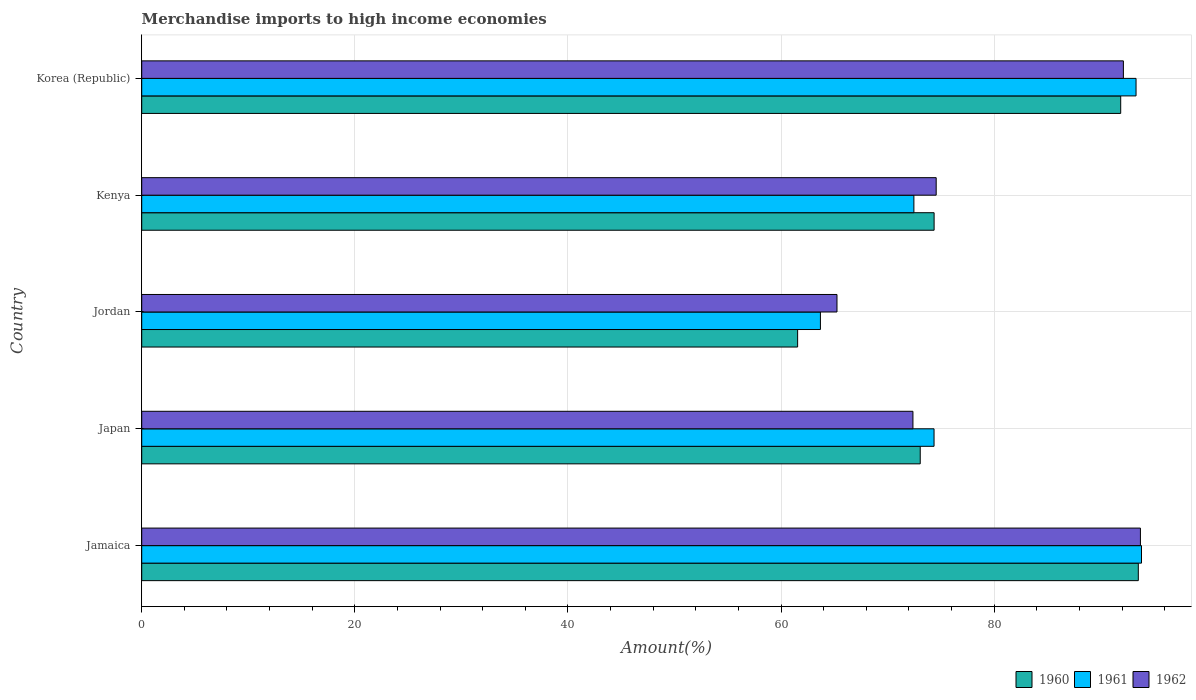How many different coloured bars are there?
Your answer should be compact. 3. How many bars are there on the 5th tick from the top?
Your answer should be compact. 3. How many bars are there on the 5th tick from the bottom?
Your answer should be very brief. 3. What is the label of the 3rd group of bars from the top?
Ensure brevity in your answer.  Jordan. What is the percentage of amount earned from merchandise imports in 1960 in Japan?
Your answer should be very brief. 73.06. Across all countries, what is the maximum percentage of amount earned from merchandise imports in 1960?
Make the answer very short. 93.52. Across all countries, what is the minimum percentage of amount earned from merchandise imports in 1962?
Provide a succinct answer. 65.24. In which country was the percentage of amount earned from merchandise imports in 1961 maximum?
Ensure brevity in your answer.  Jamaica. In which country was the percentage of amount earned from merchandise imports in 1962 minimum?
Provide a succinct answer. Jordan. What is the total percentage of amount earned from merchandise imports in 1961 in the graph?
Your response must be concise. 397.64. What is the difference between the percentage of amount earned from merchandise imports in 1962 in Jordan and that in Kenya?
Provide a short and direct response. -9.31. What is the difference between the percentage of amount earned from merchandise imports in 1962 in Jordan and the percentage of amount earned from merchandise imports in 1960 in Kenya?
Give a very brief answer. -9.11. What is the average percentage of amount earned from merchandise imports in 1960 per country?
Your response must be concise. 78.87. What is the difference between the percentage of amount earned from merchandise imports in 1961 and percentage of amount earned from merchandise imports in 1962 in Jordan?
Offer a very short reply. -1.55. What is the ratio of the percentage of amount earned from merchandise imports in 1962 in Jamaica to that in Jordan?
Keep it short and to the point. 1.44. Is the percentage of amount earned from merchandise imports in 1960 in Japan less than that in Korea (Republic)?
Make the answer very short. Yes. What is the difference between the highest and the second highest percentage of amount earned from merchandise imports in 1961?
Give a very brief answer. 0.51. What is the difference between the highest and the lowest percentage of amount earned from merchandise imports in 1961?
Keep it short and to the point. 30.13. In how many countries, is the percentage of amount earned from merchandise imports in 1962 greater than the average percentage of amount earned from merchandise imports in 1962 taken over all countries?
Provide a succinct answer. 2. Is the sum of the percentage of amount earned from merchandise imports in 1961 in Jordan and Kenya greater than the maximum percentage of amount earned from merchandise imports in 1960 across all countries?
Provide a short and direct response. Yes. What is the difference between two consecutive major ticks on the X-axis?
Your response must be concise. 20. Does the graph contain any zero values?
Ensure brevity in your answer.  No. Does the graph contain grids?
Ensure brevity in your answer.  Yes. Where does the legend appear in the graph?
Give a very brief answer. Bottom right. How many legend labels are there?
Offer a terse response. 3. What is the title of the graph?
Keep it short and to the point. Merchandise imports to high income economies. Does "2005" appear as one of the legend labels in the graph?
Keep it short and to the point. No. What is the label or title of the X-axis?
Offer a very short reply. Amount(%). What is the label or title of the Y-axis?
Offer a very short reply. Country. What is the Amount(%) in 1960 in Jamaica?
Offer a terse response. 93.52. What is the Amount(%) of 1961 in Jamaica?
Ensure brevity in your answer.  93.82. What is the Amount(%) in 1962 in Jamaica?
Provide a short and direct response. 93.72. What is the Amount(%) of 1960 in Japan?
Make the answer very short. 73.06. What is the Amount(%) of 1961 in Japan?
Keep it short and to the point. 74.35. What is the Amount(%) in 1962 in Japan?
Your answer should be very brief. 72.37. What is the Amount(%) in 1960 in Jordan?
Your answer should be compact. 61.55. What is the Amount(%) in 1961 in Jordan?
Provide a succinct answer. 63.69. What is the Amount(%) in 1962 in Jordan?
Your answer should be compact. 65.24. What is the Amount(%) of 1960 in Kenya?
Your answer should be compact. 74.36. What is the Amount(%) in 1961 in Kenya?
Your response must be concise. 72.46. What is the Amount(%) of 1962 in Kenya?
Provide a succinct answer. 74.55. What is the Amount(%) of 1960 in Korea (Republic)?
Provide a short and direct response. 91.87. What is the Amount(%) of 1961 in Korea (Republic)?
Keep it short and to the point. 93.31. What is the Amount(%) in 1962 in Korea (Republic)?
Offer a very short reply. 92.12. Across all countries, what is the maximum Amount(%) in 1960?
Offer a terse response. 93.52. Across all countries, what is the maximum Amount(%) in 1961?
Provide a short and direct response. 93.82. Across all countries, what is the maximum Amount(%) of 1962?
Ensure brevity in your answer.  93.72. Across all countries, what is the minimum Amount(%) of 1960?
Give a very brief answer. 61.55. Across all countries, what is the minimum Amount(%) of 1961?
Your answer should be compact. 63.69. Across all countries, what is the minimum Amount(%) of 1962?
Offer a very short reply. 65.24. What is the total Amount(%) in 1960 in the graph?
Offer a terse response. 394.36. What is the total Amount(%) in 1961 in the graph?
Your answer should be compact. 397.64. What is the total Amount(%) in 1962 in the graph?
Offer a terse response. 398.01. What is the difference between the Amount(%) in 1960 in Jamaica and that in Japan?
Provide a short and direct response. 20.46. What is the difference between the Amount(%) of 1961 in Jamaica and that in Japan?
Offer a very short reply. 19.47. What is the difference between the Amount(%) in 1962 in Jamaica and that in Japan?
Your answer should be very brief. 21.35. What is the difference between the Amount(%) of 1960 in Jamaica and that in Jordan?
Your answer should be very brief. 31.97. What is the difference between the Amount(%) of 1961 in Jamaica and that in Jordan?
Your response must be concise. 30.13. What is the difference between the Amount(%) in 1962 in Jamaica and that in Jordan?
Keep it short and to the point. 28.47. What is the difference between the Amount(%) in 1960 in Jamaica and that in Kenya?
Make the answer very short. 19.16. What is the difference between the Amount(%) of 1961 in Jamaica and that in Kenya?
Offer a terse response. 21.36. What is the difference between the Amount(%) of 1962 in Jamaica and that in Kenya?
Give a very brief answer. 19.16. What is the difference between the Amount(%) of 1960 in Jamaica and that in Korea (Republic)?
Ensure brevity in your answer.  1.65. What is the difference between the Amount(%) in 1961 in Jamaica and that in Korea (Republic)?
Offer a very short reply. 0.51. What is the difference between the Amount(%) of 1962 in Jamaica and that in Korea (Republic)?
Offer a very short reply. 1.6. What is the difference between the Amount(%) in 1960 in Japan and that in Jordan?
Provide a succinct answer. 11.51. What is the difference between the Amount(%) in 1961 in Japan and that in Jordan?
Your response must be concise. 10.66. What is the difference between the Amount(%) of 1962 in Japan and that in Jordan?
Provide a succinct answer. 7.13. What is the difference between the Amount(%) in 1960 in Japan and that in Kenya?
Offer a very short reply. -1.3. What is the difference between the Amount(%) of 1961 in Japan and that in Kenya?
Make the answer very short. 1.89. What is the difference between the Amount(%) in 1962 in Japan and that in Kenya?
Your answer should be compact. -2.18. What is the difference between the Amount(%) of 1960 in Japan and that in Korea (Republic)?
Your answer should be compact. -18.81. What is the difference between the Amount(%) of 1961 in Japan and that in Korea (Republic)?
Give a very brief answer. -18.96. What is the difference between the Amount(%) of 1962 in Japan and that in Korea (Republic)?
Give a very brief answer. -19.75. What is the difference between the Amount(%) of 1960 in Jordan and that in Kenya?
Keep it short and to the point. -12.81. What is the difference between the Amount(%) of 1961 in Jordan and that in Kenya?
Your response must be concise. -8.77. What is the difference between the Amount(%) in 1962 in Jordan and that in Kenya?
Your response must be concise. -9.31. What is the difference between the Amount(%) of 1960 in Jordan and that in Korea (Republic)?
Your answer should be compact. -30.32. What is the difference between the Amount(%) of 1961 in Jordan and that in Korea (Republic)?
Offer a terse response. -29.62. What is the difference between the Amount(%) in 1962 in Jordan and that in Korea (Republic)?
Your answer should be compact. -26.88. What is the difference between the Amount(%) in 1960 in Kenya and that in Korea (Republic)?
Provide a succinct answer. -17.51. What is the difference between the Amount(%) in 1961 in Kenya and that in Korea (Republic)?
Give a very brief answer. -20.85. What is the difference between the Amount(%) in 1962 in Kenya and that in Korea (Republic)?
Offer a terse response. -17.57. What is the difference between the Amount(%) of 1960 in Jamaica and the Amount(%) of 1961 in Japan?
Provide a short and direct response. 19.17. What is the difference between the Amount(%) in 1960 in Jamaica and the Amount(%) in 1962 in Japan?
Your response must be concise. 21.15. What is the difference between the Amount(%) in 1961 in Jamaica and the Amount(%) in 1962 in Japan?
Your answer should be very brief. 21.45. What is the difference between the Amount(%) of 1960 in Jamaica and the Amount(%) of 1961 in Jordan?
Offer a very short reply. 29.83. What is the difference between the Amount(%) of 1960 in Jamaica and the Amount(%) of 1962 in Jordan?
Ensure brevity in your answer.  28.28. What is the difference between the Amount(%) in 1961 in Jamaica and the Amount(%) in 1962 in Jordan?
Offer a terse response. 28.58. What is the difference between the Amount(%) of 1960 in Jamaica and the Amount(%) of 1961 in Kenya?
Offer a very short reply. 21.06. What is the difference between the Amount(%) in 1960 in Jamaica and the Amount(%) in 1962 in Kenya?
Your response must be concise. 18.97. What is the difference between the Amount(%) in 1961 in Jamaica and the Amount(%) in 1962 in Kenya?
Offer a terse response. 19.27. What is the difference between the Amount(%) in 1960 in Jamaica and the Amount(%) in 1961 in Korea (Republic)?
Your answer should be very brief. 0.21. What is the difference between the Amount(%) in 1960 in Jamaica and the Amount(%) in 1962 in Korea (Republic)?
Keep it short and to the point. 1.4. What is the difference between the Amount(%) in 1961 in Jamaica and the Amount(%) in 1962 in Korea (Republic)?
Make the answer very short. 1.7. What is the difference between the Amount(%) of 1960 in Japan and the Amount(%) of 1961 in Jordan?
Ensure brevity in your answer.  9.37. What is the difference between the Amount(%) in 1960 in Japan and the Amount(%) in 1962 in Jordan?
Offer a very short reply. 7.81. What is the difference between the Amount(%) in 1961 in Japan and the Amount(%) in 1962 in Jordan?
Provide a succinct answer. 9.11. What is the difference between the Amount(%) of 1960 in Japan and the Amount(%) of 1961 in Kenya?
Your answer should be very brief. 0.59. What is the difference between the Amount(%) of 1960 in Japan and the Amount(%) of 1962 in Kenya?
Offer a very short reply. -1.5. What is the difference between the Amount(%) in 1961 in Japan and the Amount(%) in 1962 in Kenya?
Offer a very short reply. -0.2. What is the difference between the Amount(%) in 1960 in Japan and the Amount(%) in 1961 in Korea (Republic)?
Ensure brevity in your answer.  -20.25. What is the difference between the Amount(%) in 1960 in Japan and the Amount(%) in 1962 in Korea (Republic)?
Your answer should be very brief. -19.06. What is the difference between the Amount(%) in 1961 in Japan and the Amount(%) in 1962 in Korea (Republic)?
Give a very brief answer. -17.77. What is the difference between the Amount(%) of 1960 in Jordan and the Amount(%) of 1961 in Kenya?
Offer a terse response. -10.91. What is the difference between the Amount(%) in 1960 in Jordan and the Amount(%) in 1962 in Kenya?
Give a very brief answer. -13. What is the difference between the Amount(%) of 1961 in Jordan and the Amount(%) of 1962 in Kenya?
Your response must be concise. -10.86. What is the difference between the Amount(%) of 1960 in Jordan and the Amount(%) of 1961 in Korea (Republic)?
Your answer should be compact. -31.76. What is the difference between the Amount(%) in 1960 in Jordan and the Amount(%) in 1962 in Korea (Republic)?
Keep it short and to the point. -30.57. What is the difference between the Amount(%) of 1961 in Jordan and the Amount(%) of 1962 in Korea (Republic)?
Give a very brief answer. -28.43. What is the difference between the Amount(%) of 1960 in Kenya and the Amount(%) of 1961 in Korea (Republic)?
Provide a short and direct response. -18.95. What is the difference between the Amount(%) in 1960 in Kenya and the Amount(%) in 1962 in Korea (Republic)?
Offer a terse response. -17.76. What is the difference between the Amount(%) in 1961 in Kenya and the Amount(%) in 1962 in Korea (Republic)?
Offer a terse response. -19.66. What is the average Amount(%) of 1960 per country?
Ensure brevity in your answer.  78.87. What is the average Amount(%) of 1961 per country?
Offer a terse response. 79.53. What is the average Amount(%) of 1962 per country?
Provide a short and direct response. 79.6. What is the difference between the Amount(%) of 1960 and Amount(%) of 1961 in Jamaica?
Make the answer very short. -0.3. What is the difference between the Amount(%) in 1960 and Amount(%) in 1962 in Jamaica?
Offer a terse response. -0.2. What is the difference between the Amount(%) in 1961 and Amount(%) in 1962 in Jamaica?
Make the answer very short. 0.1. What is the difference between the Amount(%) in 1960 and Amount(%) in 1961 in Japan?
Give a very brief answer. -1.3. What is the difference between the Amount(%) of 1960 and Amount(%) of 1962 in Japan?
Provide a succinct answer. 0.68. What is the difference between the Amount(%) of 1961 and Amount(%) of 1962 in Japan?
Give a very brief answer. 1.98. What is the difference between the Amount(%) of 1960 and Amount(%) of 1961 in Jordan?
Make the answer very short. -2.14. What is the difference between the Amount(%) of 1960 and Amount(%) of 1962 in Jordan?
Your answer should be very brief. -3.69. What is the difference between the Amount(%) in 1961 and Amount(%) in 1962 in Jordan?
Keep it short and to the point. -1.55. What is the difference between the Amount(%) of 1960 and Amount(%) of 1961 in Kenya?
Offer a terse response. 1.9. What is the difference between the Amount(%) of 1960 and Amount(%) of 1962 in Kenya?
Offer a very short reply. -0.2. What is the difference between the Amount(%) of 1961 and Amount(%) of 1962 in Kenya?
Offer a very short reply. -2.09. What is the difference between the Amount(%) of 1960 and Amount(%) of 1961 in Korea (Republic)?
Offer a terse response. -1.44. What is the difference between the Amount(%) in 1960 and Amount(%) in 1962 in Korea (Republic)?
Make the answer very short. -0.25. What is the difference between the Amount(%) in 1961 and Amount(%) in 1962 in Korea (Republic)?
Offer a terse response. 1.19. What is the ratio of the Amount(%) of 1960 in Jamaica to that in Japan?
Keep it short and to the point. 1.28. What is the ratio of the Amount(%) in 1961 in Jamaica to that in Japan?
Offer a terse response. 1.26. What is the ratio of the Amount(%) of 1962 in Jamaica to that in Japan?
Offer a terse response. 1.29. What is the ratio of the Amount(%) in 1960 in Jamaica to that in Jordan?
Provide a succinct answer. 1.52. What is the ratio of the Amount(%) of 1961 in Jamaica to that in Jordan?
Offer a terse response. 1.47. What is the ratio of the Amount(%) of 1962 in Jamaica to that in Jordan?
Your answer should be compact. 1.44. What is the ratio of the Amount(%) in 1960 in Jamaica to that in Kenya?
Ensure brevity in your answer.  1.26. What is the ratio of the Amount(%) of 1961 in Jamaica to that in Kenya?
Offer a terse response. 1.29. What is the ratio of the Amount(%) of 1962 in Jamaica to that in Kenya?
Offer a very short reply. 1.26. What is the ratio of the Amount(%) of 1960 in Jamaica to that in Korea (Republic)?
Your response must be concise. 1.02. What is the ratio of the Amount(%) of 1962 in Jamaica to that in Korea (Republic)?
Your answer should be very brief. 1.02. What is the ratio of the Amount(%) in 1960 in Japan to that in Jordan?
Keep it short and to the point. 1.19. What is the ratio of the Amount(%) of 1961 in Japan to that in Jordan?
Keep it short and to the point. 1.17. What is the ratio of the Amount(%) of 1962 in Japan to that in Jordan?
Offer a very short reply. 1.11. What is the ratio of the Amount(%) of 1960 in Japan to that in Kenya?
Make the answer very short. 0.98. What is the ratio of the Amount(%) of 1961 in Japan to that in Kenya?
Offer a terse response. 1.03. What is the ratio of the Amount(%) of 1962 in Japan to that in Kenya?
Make the answer very short. 0.97. What is the ratio of the Amount(%) in 1960 in Japan to that in Korea (Republic)?
Your answer should be compact. 0.8. What is the ratio of the Amount(%) of 1961 in Japan to that in Korea (Republic)?
Your answer should be compact. 0.8. What is the ratio of the Amount(%) of 1962 in Japan to that in Korea (Republic)?
Your answer should be compact. 0.79. What is the ratio of the Amount(%) in 1960 in Jordan to that in Kenya?
Provide a short and direct response. 0.83. What is the ratio of the Amount(%) of 1961 in Jordan to that in Kenya?
Give a very brief answer. 0.88. What is the ratio of the Amount(%) of 1962 in Jordan to that in Kenya?
Provide a succinct answer. 0.88. What is the ratio of the Amount(%) of 1960 in Jordan to that in Korea (Republic)?
Provide a short and direct response. 0.67. What is the ratio of the Amount(%) of 1961 in Jordan to that in Korea (Republic)?
Make the answer very short. 0.68. What is the ratio of the Amount(%) in 1962 in Jordan to that in Korea (Republic)?
Provide a short and direct response. 0.71. What is the ratio of the Amount(%) of 1960 in Kenya to that in Korea (Republic)?
Make the answer very short. 0.81. What is the ratio of the Amount(%) in 1961 in Kenya to that in Korea (Republic)?
Offer a terse response. 0.78. What is the ratio of the Amount(%) in 1962 in Kenya to that in Korea (Republic)?
Provide a short and direct response. 0.81. What is the difference between the highest and the second highest Amount(%) of 1960?
Provide a succinct answer. 1.65. What is the difference between the highest and the second highest Amount(%) in 1961?
Provide a short and direct response. 0.51. What is the difference between the highest and the second highest Amount(%) of 1962?
Offer a terse response. 1.6. What is the difference between the highest and the lowest Amount(%) in 1960?
Provide a succinct answer. 31.97. What is the difference between the highest and the lowest Amount(%) in 1961?
Offer a very short reply. 30.13. What is the difference between the highest and the lowest Amount(%) in 1962?
Your response must be concise. 28.47. 